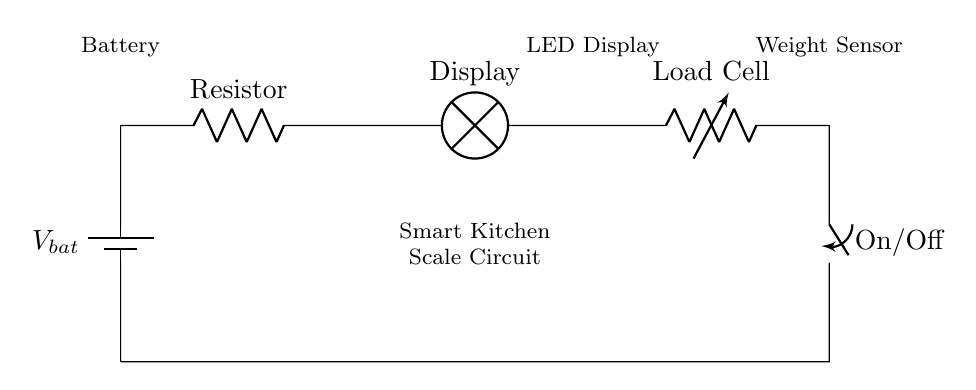what is the power source in this circuit? The power source is indicated by the battery symbol, which supplies voltage to the circuit components.
Answer: Battery what type of load is represented in this circuit? The load is represented by the load cell, commonly used in scales to measure weight by generating an output signal based on applied weight.
Answer: Load Cell how many resistors are present in this circuit? There is one resistor shown in the circuit diagram, which is linked in series with other components.
Answer: One what is the purpose of the switch in this circuit? The switch provides the ability to manually turn the circuit on or off, interrupting the current flow when in the off position.
Answer: On/Off if the battery voltage is 9 volts, what is the potential difference across the display? In a series circuit, the voltage is divided among the components. If the battery is 9 volts, each component's voltage drop would depend on their resistance, but ideally, the display would require a specific voltage based on its design (commonly around 5V). Since the total is 9V, and assuming other components don't drop significant voltage, it could be about 5V.
Answer: About 5V what kind of circuit configuration is used in the diagram? The circuit is a series configuration where all components are connected end-to-end, allowing current to flow through each part consecutively.
Answer: Series how does the weight sensor affect the circuit? The weight sensor (load cell) generates a change in electrical signal based on the weight applied, affecting the overall circuit's current and potentially the voltage across the display.
Answer: Generates signal based on weight 